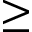<formula> <loc_0><loc_0><loc_500><loc_500>\geq</formula> 